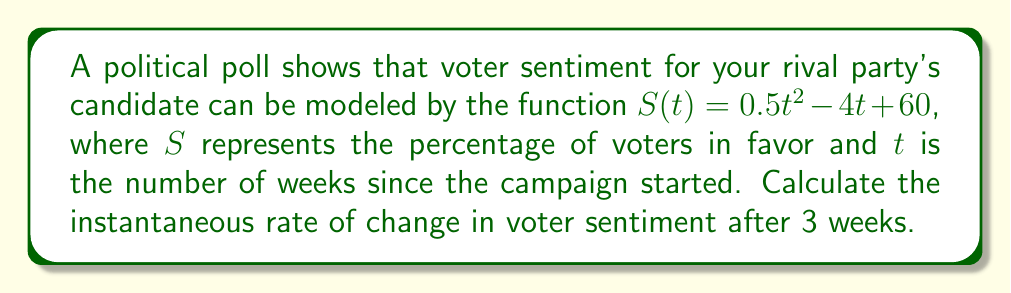Could you help me with this problem? To find the instantaneous rate of change, we need to calculate the derivative of the function $S(t)$ and evaluate it at $t = 3$.

1. Given function: $S(t) = 0.5t^2 - 4t + 60$

2. Calculate the derivative $S'(t)$:
   $$\frac{d}{dt}[0.5t^2] = t$$
   $$\frac{d}{dt}[-4t] = -4$$
   $$\frac{d}{dt}[60] = 0$$

   Therefore, $S'(t) = t - 4$

3. Evaluate $S'(t)$ at $t = 3$:
   $S'(3) = 3 - 4 = -1$

The negative value indicates that voter sentiment for the rival party's candidate is decreasing at this point in time.
Answer: $-1$ percentage point per week 